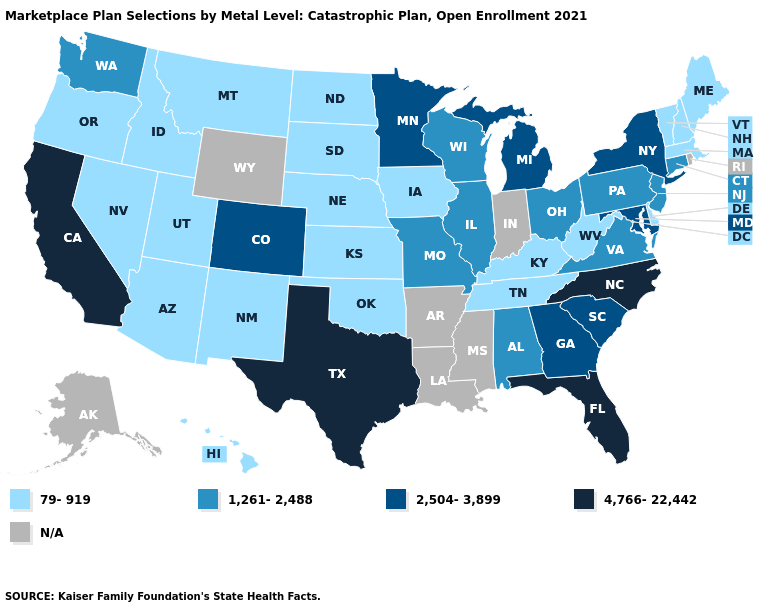Does South Dakota have the lowest value in the MidWest?
Quick response, please. Yes. What is the value of Kentucky?
Keep it brief. 79-919. What is the value of Ohio?
Answer briefly. 1,261-2,488. How many symbols are there in the legend?
Keep it brief. 5. Name the states that have a value in the range 4,766-22,442?
Concise answer only. California, Florida, North Carolina, Texas. Name the states that have a value in the range 1,261-2,488?
Keep it brief. Alabama, Connecticut, Illinois, Missouri, New Jersey, Ohio, Pennsylvania, Virginia, Washington, Wisconsin. Does New York have the lowest value in the USA?
Be succinct. No. What is the value of Florida?
Short answer required. 4,766-22,442. What is the value of New York?
Write a very short answer. 2,504-3,899. How many symbols are there in the legend?
Answer briefly. 5. What is the value of New Jersey?
Give a very brief answer. 1,261-2,488. Among the states that border Ohio , which have the lowest value?
Quick response, please. Kentucky, West Virginia. Does the map have missing data?
Keep it brief. Yes. Which states have the lowest value in the West?
Quick response, please. Arizona, Hawaii, Idaho, Montana, Nevada, New Mexico, Oregon, Utah. 